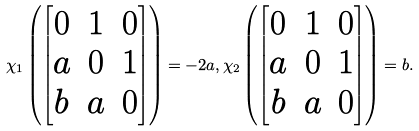<formula> <loc_0><loc_0><loc_500><loc_500>\chi _ { 1 } \left ( \begin{bmatrix} 0 & 1 & 0 \\ a & 0 & 1 \\ b & a & 0 \end{bmatrix} \right ) = - 2 a , \chi _ { 2 } \left ( \begin{bmatrix} 0 & 1 & 0 \\ a & 0 & 1 \\ b & a & 0 \end{bmatrix} \right ) = b .</formula> 